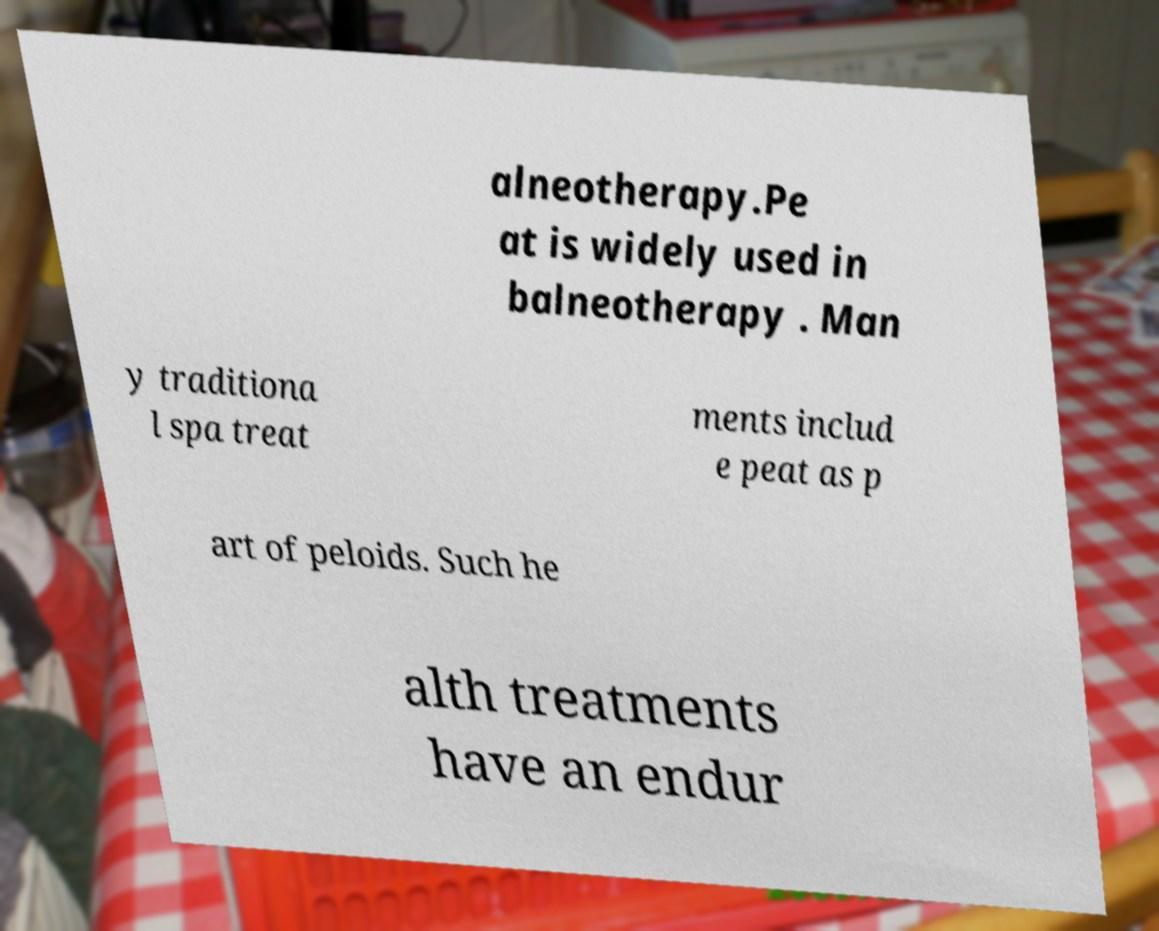What messages or text are displayed in this image? I need them in a readable, typed format. alneotherapy.Pe at is widely used in balneotherapy . Man y traditiona l spa treat ments includ e peat as p art of peloids. Such he alth treatments have an endur 